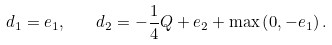Convert formula to latex. <formula><loc_0><loc_0><loc_500><loc_500>d _ { 1 } = e _ { 1 } , \quad d _ { 2 } = - \frac { 1 } { 4 } Q + e _ { 2 } + \max \left ( 0 , - e _ { 1 } \right ) .</formula> 